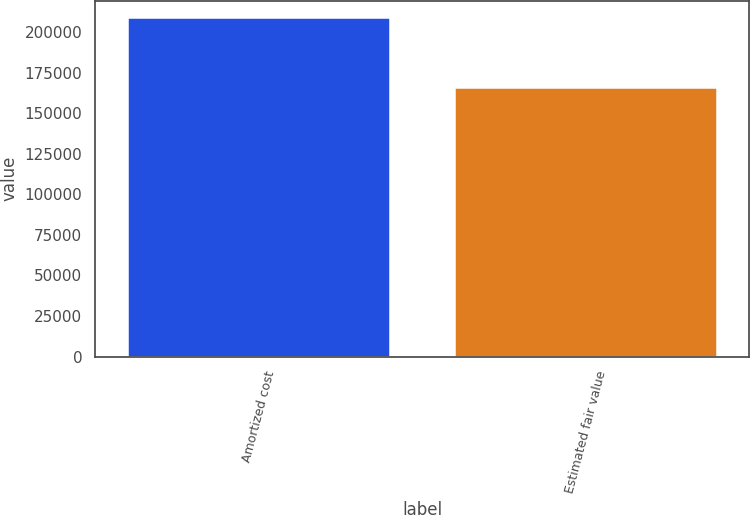Convert chart to OTSL. <chart><loc_0><loc_0><loc_500><loc_500><bar_chart><fcel>Amortized cost<fcel>Estimated fair value<nl><fcel>209107<fcel>165860<nl></chart> 